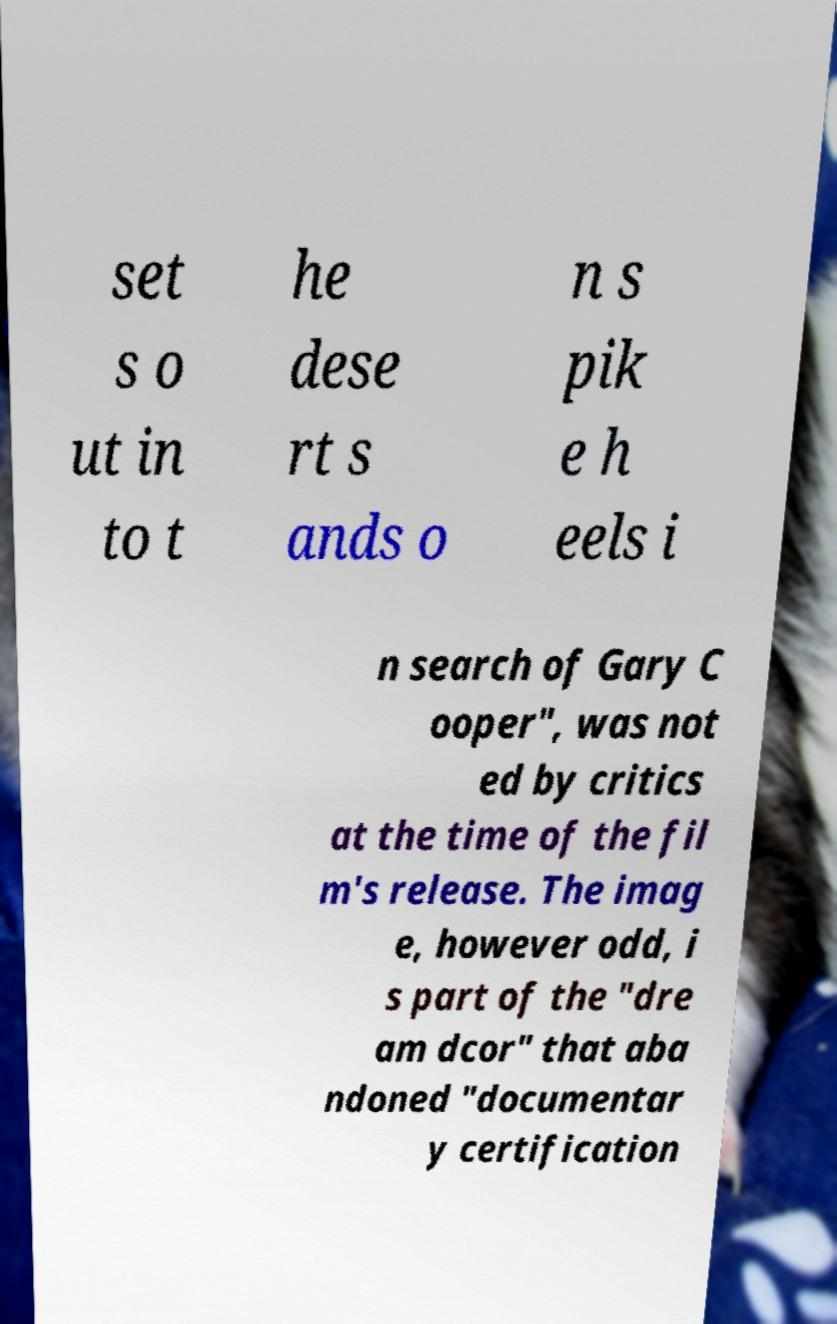Can you accurately transcribe the text from the provided image for me? set s o ut in to t he dese rt s ands o n s pik e h eels i n search of Gary C ooper", was not ed by critics at the time of the fil m's release. The imag e, however odd, i s part of the "dre am dcor" that aba ndoned "documentar y certification 